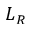Convert formula to latex. <formula><loc_0><loc_0><loc_500><loc_500>L _ { R }</formula> 